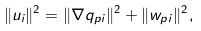Convert formula to latex. <formula><loc_0><loc_0><loc_500><loc_500>\| u _ { i } \| ^ { 2 } = \| \nabla q _ { p i } \| ^ { 2 } + \| { w } _ { p i } \| ^ { 2 } ,</formula> 